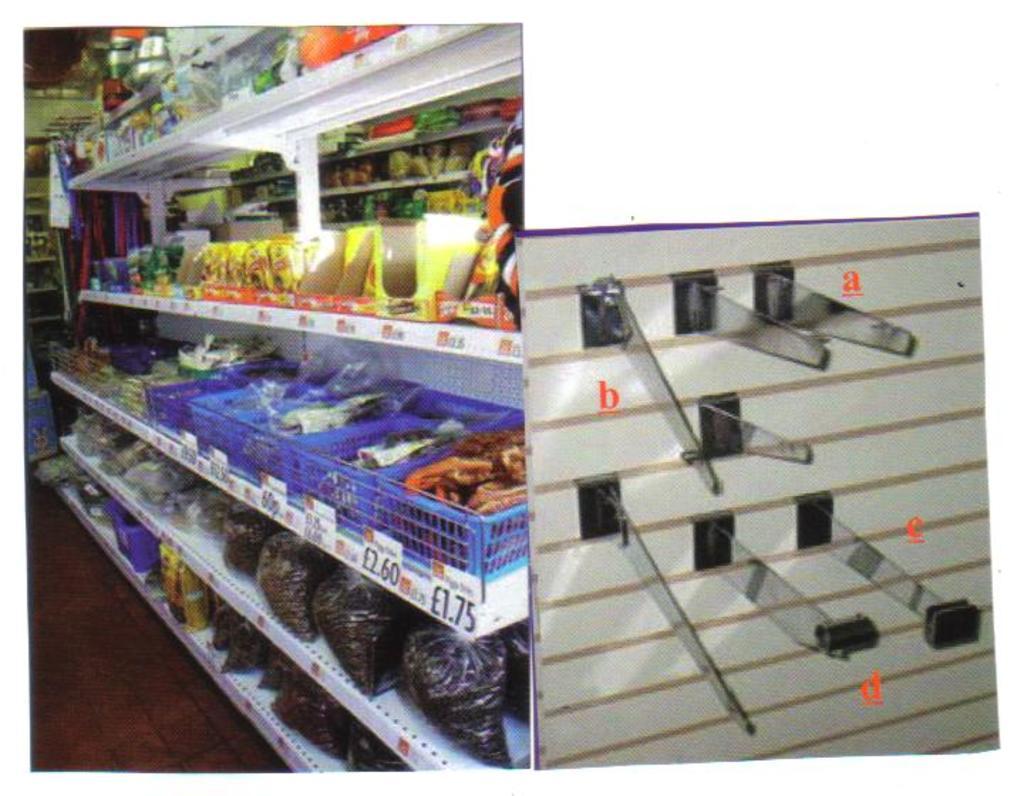How much is the last items on the second shelf?
Offer a very short reply. 1.75. 